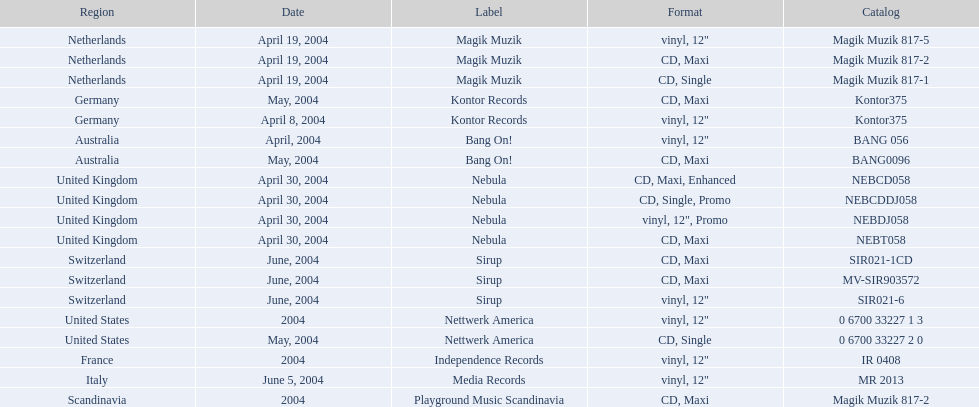What are the different tags associated with "love comes again"? Magik Muzik, Magik Muzik, Magik Muzik, Kontor Records, Kontor Records, Bang On!, Bang On!, Nebula, Nebula, Nebula, Nebula, Sirup, Sirup, Sirup, Nettwerk America, Nettwerk America, Independence Records, Media Records, Playground Music Scandinavia. Which label is utilized by the french region? Independence Records. 